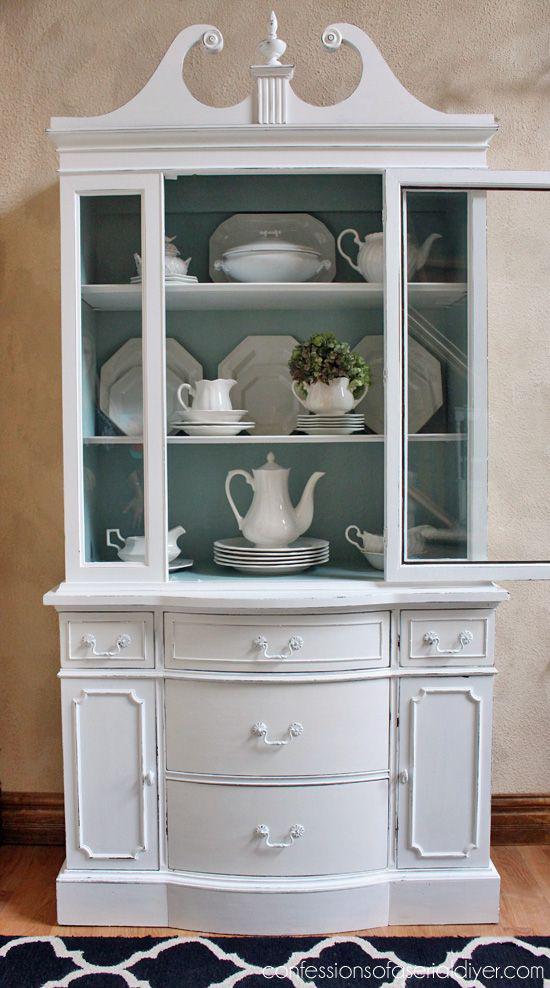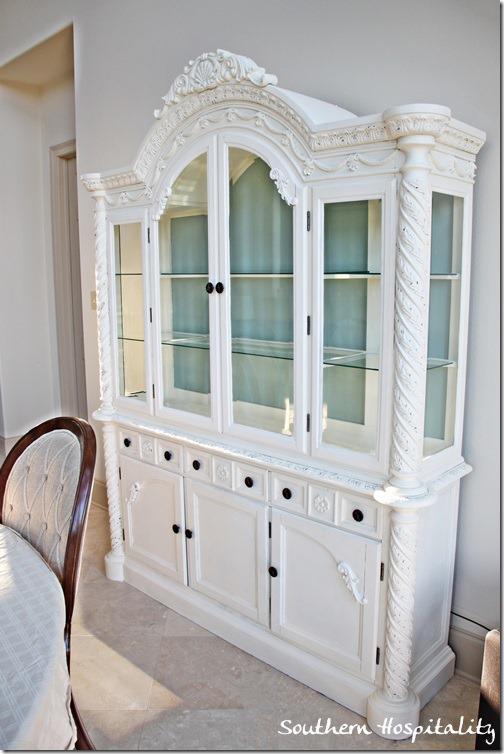The first image is the image on the left, the second image is the image on the right. Examine the images to the left and right. Is the description "A wreath is hanging on a white china cabinet." accurate? Answer yes or no. No. The first image is the image on the left, the second image is the image on the right. For the images shown, is this caption "The right image has a cabinet with a green wreath hanging on it." true? Answer yes or no. No. 